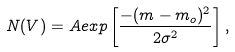Convert formula to latex. <formula><loc_0><loc_0><loc_500><loc_500>N ( V ) = A e x p \left [ \frac { - ( m - m _ { o } ) ^ { 2 } } { 2 \sigma ^ { 2 } } \right ] ,</formula> 